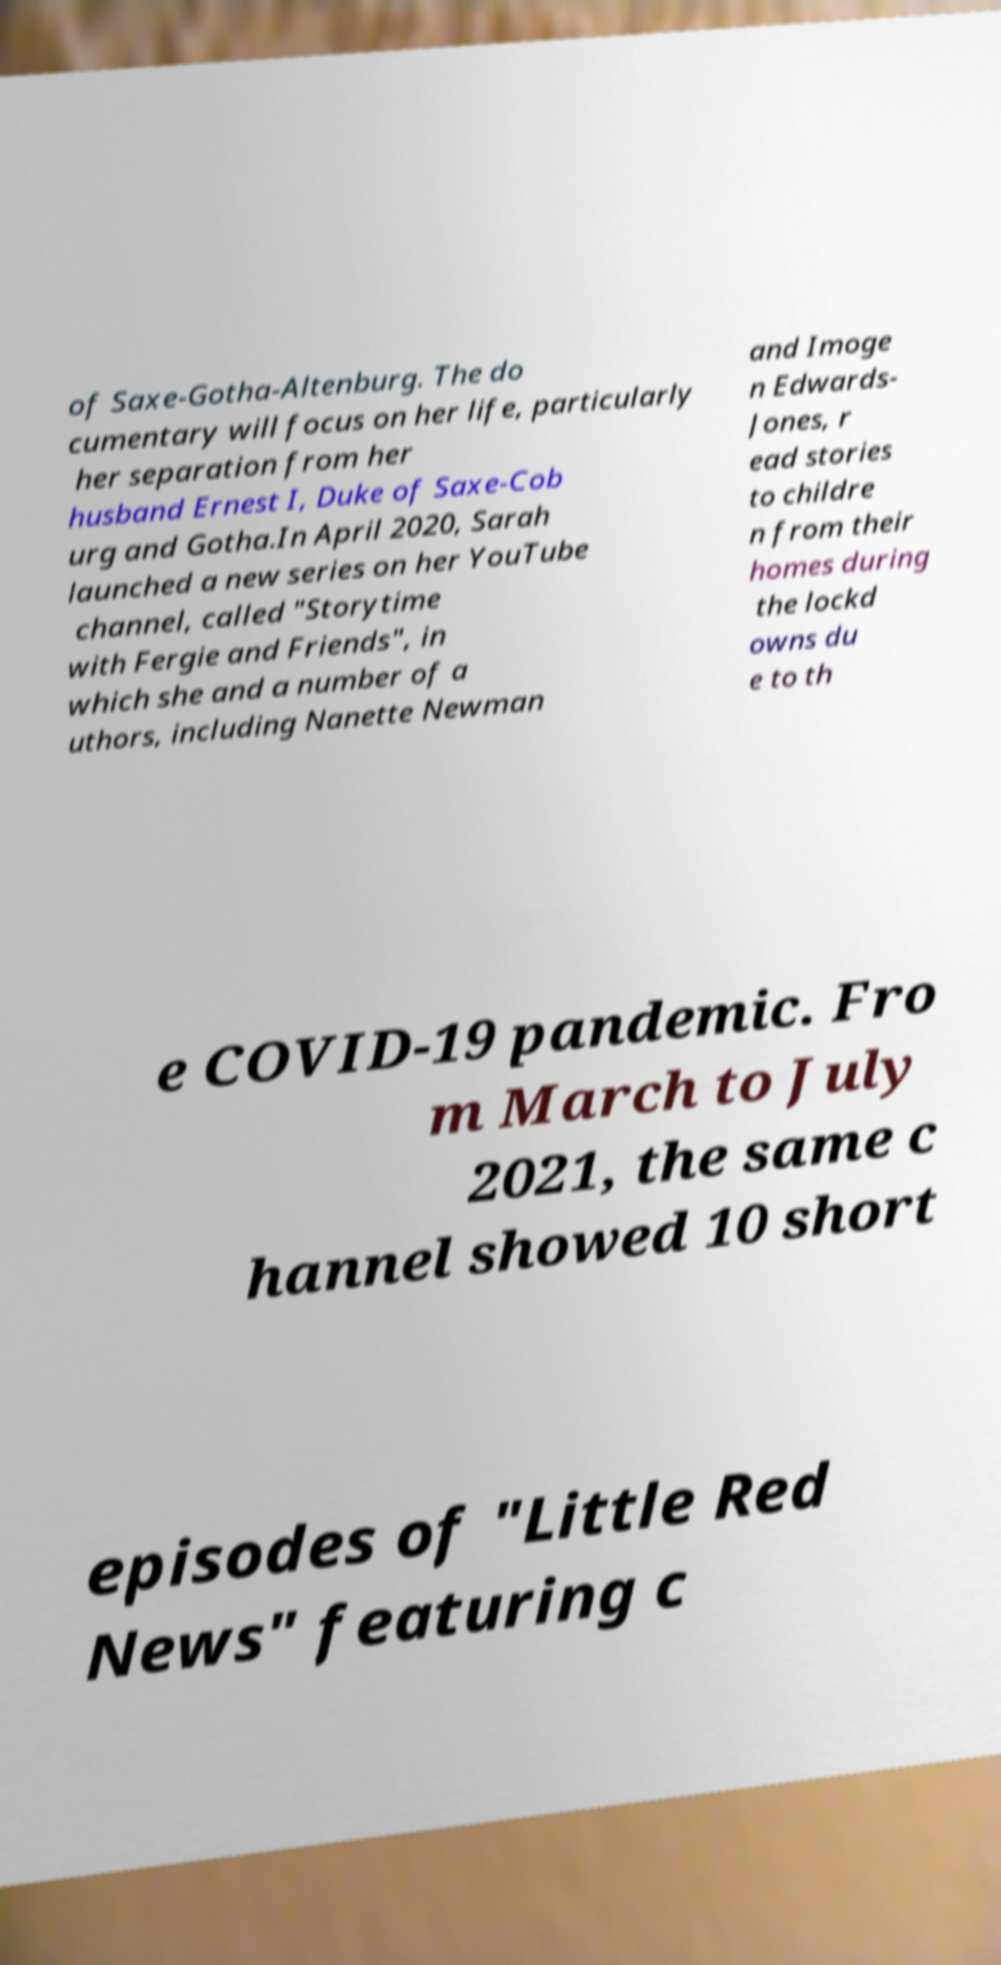I need the written content from this picture converted into text. Can you do that? of Saxe-Gotha-Altenburg. The do cumentary will focus on her life, particularly her separation from her husband Ernest I, Duke of Saxe-Cob urg and Gotha.In April 2020, Sarah launched a new series on her YouTube channel, called "Storytime with Fergie and Friends", in which she and a number of a uthors, including Nanette Newman and Imoge n Edwards- Jones, r ead stories to childre n from their homes during the lockd owns du e to th e COVID-19 pandemic. Fro m March to July 2021, the same c hannel showed 10 short episodes of "Little Red News" featuring c 